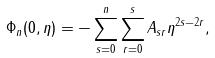<formula> <loc_0><loc_0><loc_500><loc_500>\Phi _ { n } ( 0 , \eta ) = - \sum _ { s = 0 } ^ { n } \sum _ { r = 0 } ^ { s } A _ { s r } \eta ^ { 2 s - 2 r } ,</formula> 